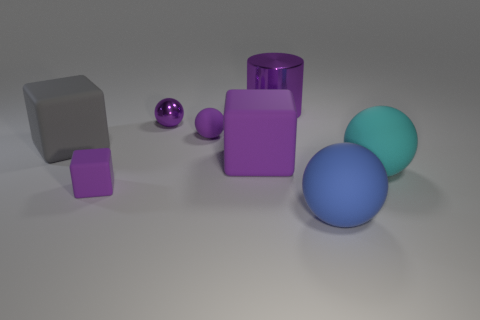There is a small object that is the same material as the tiny block; what is its color?
Ensure brevity in your answer.  Purple. What is the large gray cube made of?
Your response must be concise. Rubber. The big purple shiny object has what shape?
Offer a very short reply. Cylinder. How many big rubber objects are the same color as the small metallic sphere?
Offer a very short reply. 1. What material is the tiny purple object that is in front of the large ball that is on the right side of the big sphere on the left side of the big cyan sphere made of?
Provide a succinct answer. Rubber. What number of purple objects are tiny spheres or cylinders?
Provide a succinct answer. 3. What size is the purple object on the left side of the tiny purple thing behind the rubber sphere that is left of the cylinder?
Your answer should be compact. Small. There is a purple shiny object that is the same shape as the big blue rubber object; what size is it?
Give a very brief answer. Small. How many large things are purple metallic objects or gray objects?
Offer a terse response. 2. Does the large purple thing in front of the small metallic sphere have the same material as the large object behind the big gray rubber cube?
Your answer should be compact. No. 